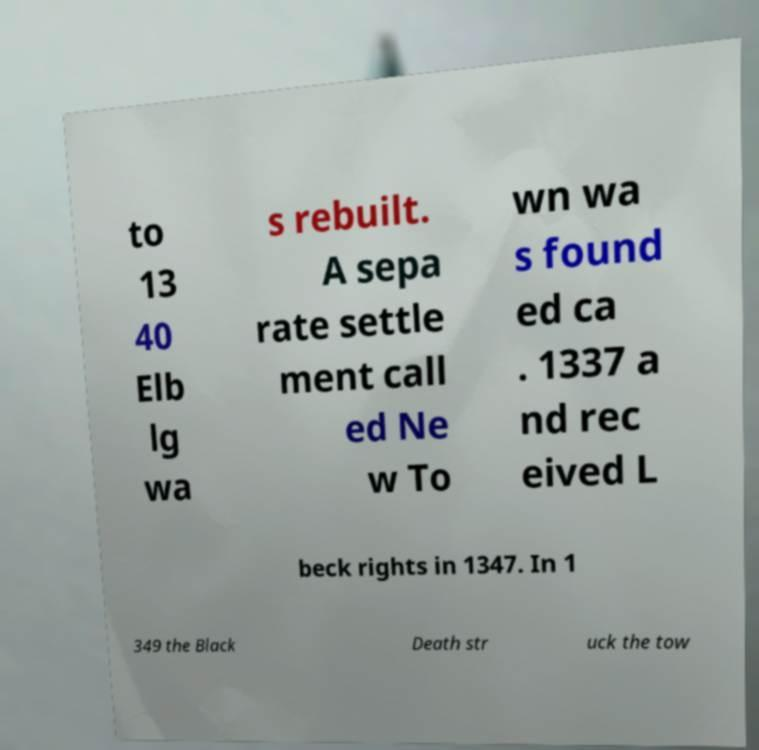Could you extract and type out the text from this image? to 13 40 Elb lg wa s rebuilt. A sepa rate settle ment call ed Ne w To wn wa s found ed ca . 1337 a nd rec eived L beck rights in 1347. In 1 349 the Black Death str uck the tow 